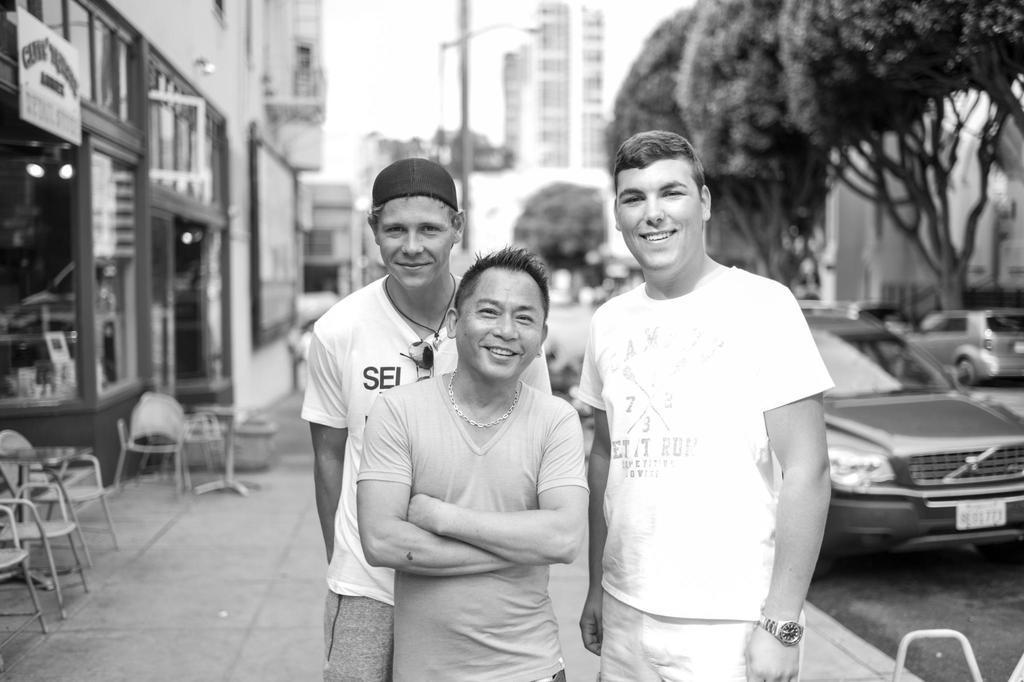In one or two sentences, can you explain what this image depicts? Black and white picture. Front these three people are standing and smiling. Background we can see buildings, trees, vehicles, pole, sky and chairs. This is board. 